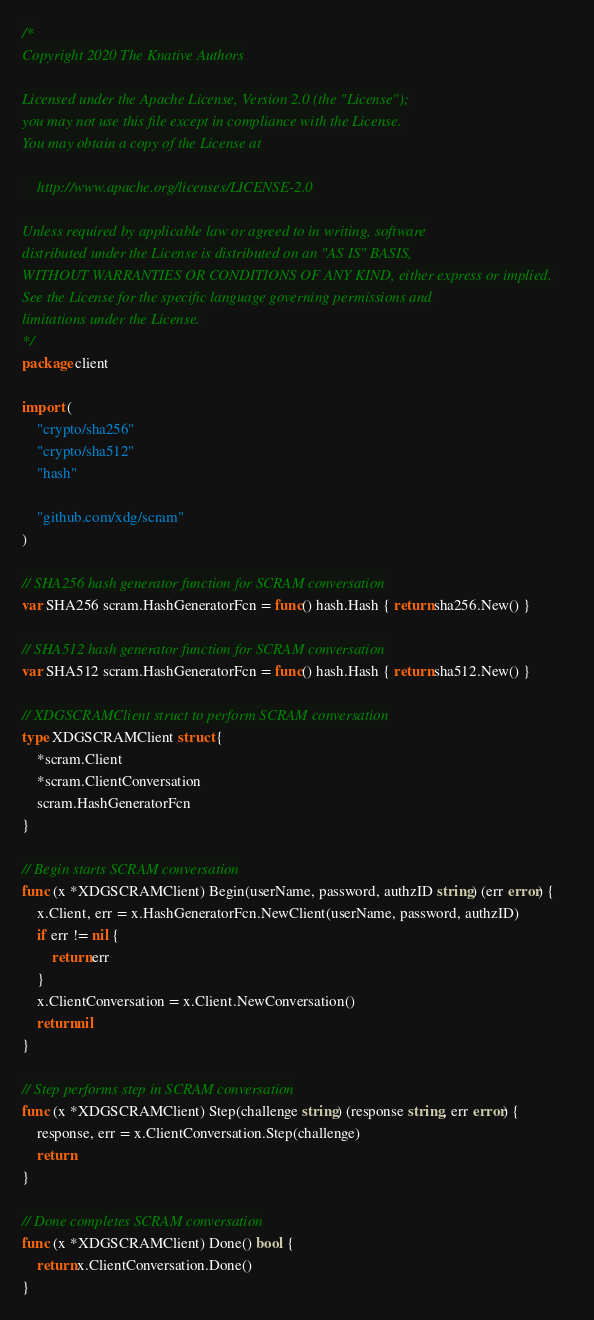<code> <loc_0><loc_0><loc_500><loc_500><_Go_>/*
Copyright 2020 The Knative Authors

Licensed under the Apache License, Version 2.0 (the "License");
you may not use this file except in compliance with the License.
You may obtain a copy of the License at

    http://www.apache.org/licenses/LICENSE-2.0

Unless required by applicable law or agreed to in writing, software
distributed under the License is distributed on an "AS IS" BASIS,
WITHOUT WARRANTIES OR CONDITIONS OF ANY KIND, either express or implied.
See the License for the specific language governing permissions and
limitations under the License.
*/
package client

import (
	"crypto/sha256"
	"crypto/sha512"
	"hash"

	"github.com/xdg/scram"
)

// SHA256 hash generator function for SCRAM conversation
var SHA256 scram.HashGeneratorFcn = func() hash.Hash { return sha256.New() }

// SHA512 hash generator function for SCRAM conversation
var SHA512 scram.HashGeneratorFcn = func() hash.Hash { return sha512.New() }

// XDGSCRAMClient struct to perform SCRAM conversation
type XDGSCRAMClient struct {
	*scram.Client
	*scram.ClientConversation
	scram.HashGeneratorFcn
}

// Begin starts SCRAM conversation
func (x *XDGSCRAMClient) Begin(userName, password, authzID string) (err error) {
	x.Client, err = x.HashGeneratorFcn.NewClient(userName, password, authzID)
	if err != nil {
		return err
	}
	x.ClientConversation = x.Client.NewConversation()
	return nil
}

// Step performs step in SCRAM conversation
func (x *XDGSCRAMClient) Step(challenge string) (response string, err error) {
	response, err = x.ClientConversation.Step(challenge)
	return
}

// Done completes SCRAM conversation
func (x *XDGSCRAMClient) Done() bool {
	return x.ClientConversation.Done()
}
</code> 